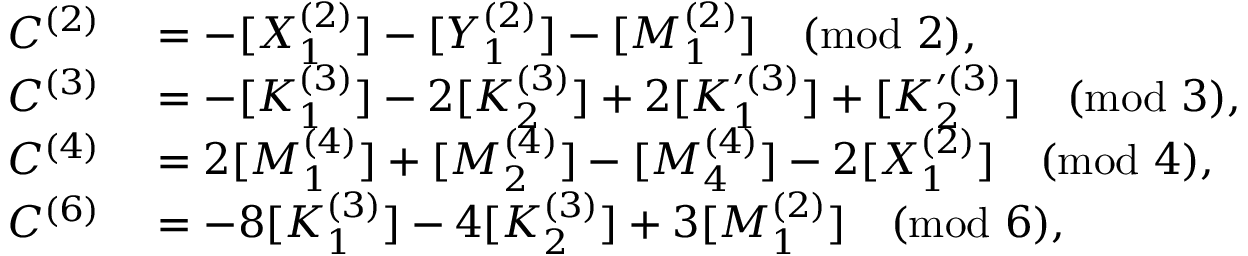<formula> <loc_0><loc_0><loc_500><loc_500>\begin{array} { r l } { C ^ { ( 2 ) } } & = - [ X _ { 1 } ^ { ( 2 ) } ] - [ Y _ { 1 } ^ { ( 2 ) } ] - [ M _ { 1 } ^ { ( 2 ) } ] \pmod { 2 } , } \\ { C ^ { ( 3 ) } } & = - [ K _ { 1 } ^ { ( 3 ) } ] - 2 [ K _ { 2 } ^ { ( 3 ) } ] + 2 [ K _ { 1 } ^ { \prime ( 3 ) } ] + [ K _ { 2 } ^ { \prime ( 3 ) } ] \pmod { 3 } , } \\ { C ^ { ( 4 ) } } & = 2 [ M _ { 1 } ^ { ( 4 ) } ] + [ M _ { 2 } ^ { ( 4 ) } ] - [ M _ { 4 } ^ { ( 4 ) } ] - 2 [ X _ { 1 } ^ { ( 2 ) } ] \pmod { 4 } , } \\ { C ^ { ( 6 ) } } & = - 8 [ K _ { 1 } ^ { ( 3 ) } ] - 4 [ K _ { 2 } ^ { ( 3 ) } ] + 3 [ M _ { 1 } ^ { ( 2 ) } ] \pmod { 6 } , } \end{array}</formula> 